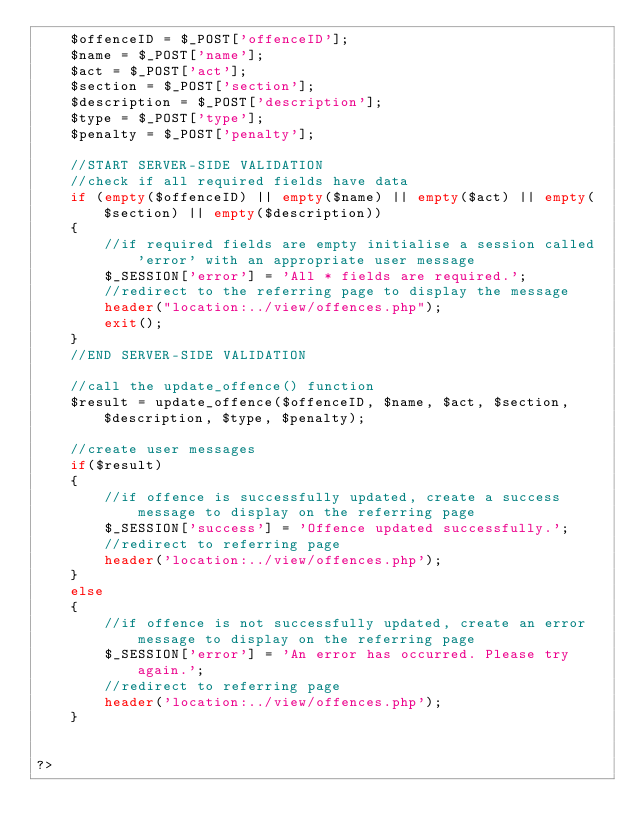Convert code to text. <code><loc_0><loc_0><loc_500><loc_500><_PHP_>    $offenceID = $_POST['offenceID'];
    $name = $_POST['name'];
    $act = $_POST['act'];
    $section = $_POST['section'];
    $description = $_POST['description'];
    $type = $_POST['type'];
    $penalty = $_POST['penalty'];

    //START SERVER-SIDE VALIDATION
    //check if all required fields have data
    if (empty($offenceID) || empty($name) || empty($act) || empty($section) || empty($description))
    {
        //if required fields are empty initialise a session called 'error' with an appropriate user message
        $_SESSION['error'] = 'All * fields are required.';
        //redirect to the referring page to display the message
        header("location:../view/offences.php");
        exit();
    }
    //END SERVER-SIDE VALIDATION

    //call the update_offence() function
    $result = update_offence($offenceID, $name, $act, $section, $description, $type, $penalty);

    //create user messages
    if($result)
    {
        //if offence is successfully updated, create a success message to display on the referring page
        $_SESSION['success'] = 'Offence updated successfully.';
        //redirect to referring page
        header('location:../view/offences.php');
    }
    else
    {
        //if offence is not successfully updated, create an error message to display on the referring page
        $_SESSION['error'] = 'An error has occurred. Please try again.';
        //redirect to referring page
        header('location:../view/offences.php');
    }


?></code> 